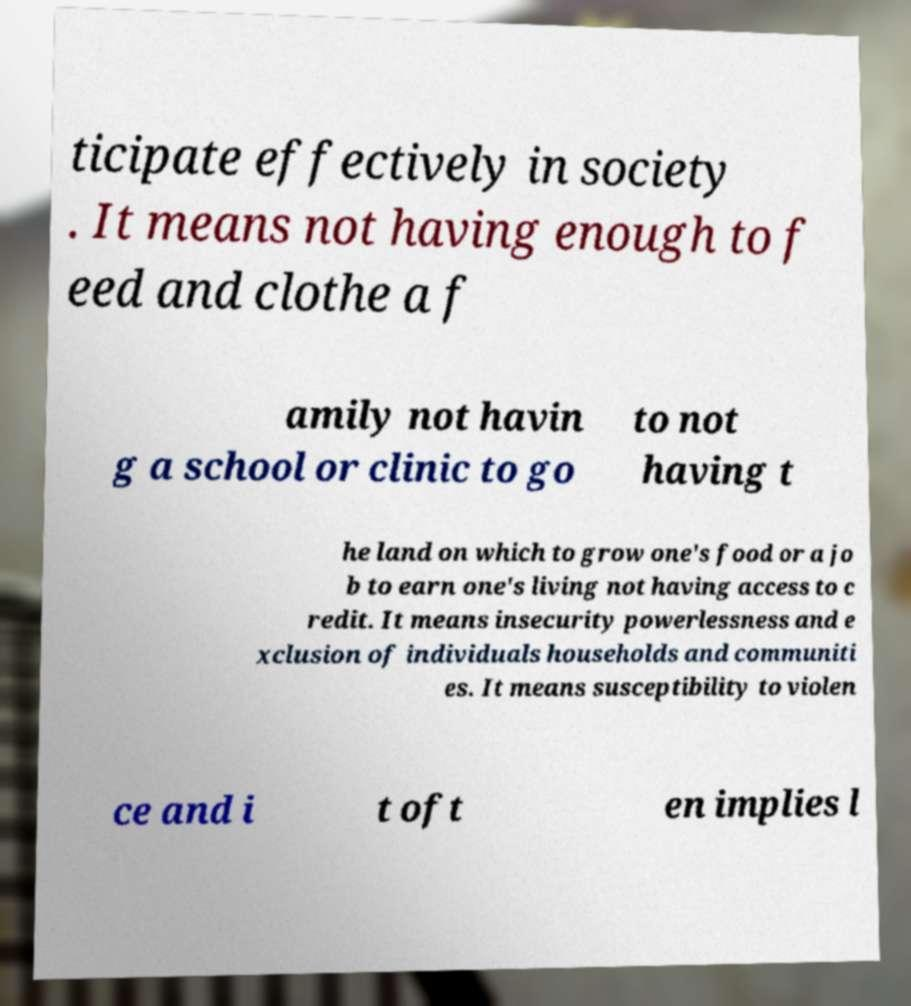I need the written content from this picture converted into text. Can you do that? ticipate effectively in society . It means not having enough to f eed and clothe a f amily not havin g a school or clinic to go to not having t he land on which to grow one's food or a jo b to earn one's living not having access to c redit. It means insecurity powerlessness and e xclusion of individuals households and communiti es. It means susceptibility to violen ce and i t oft en implies l 